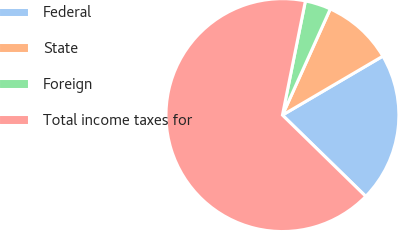<chart> <loc_0><loc_0><loc_500><loc_500><pie_chart><fcel>Federal<fcel>State<fcel>Foreign<fcel>Total income taxes for<nl><fcel>20.75%<fcel>9.81%<fcel>3.58%<fcel>65.86%<nl></chart> 